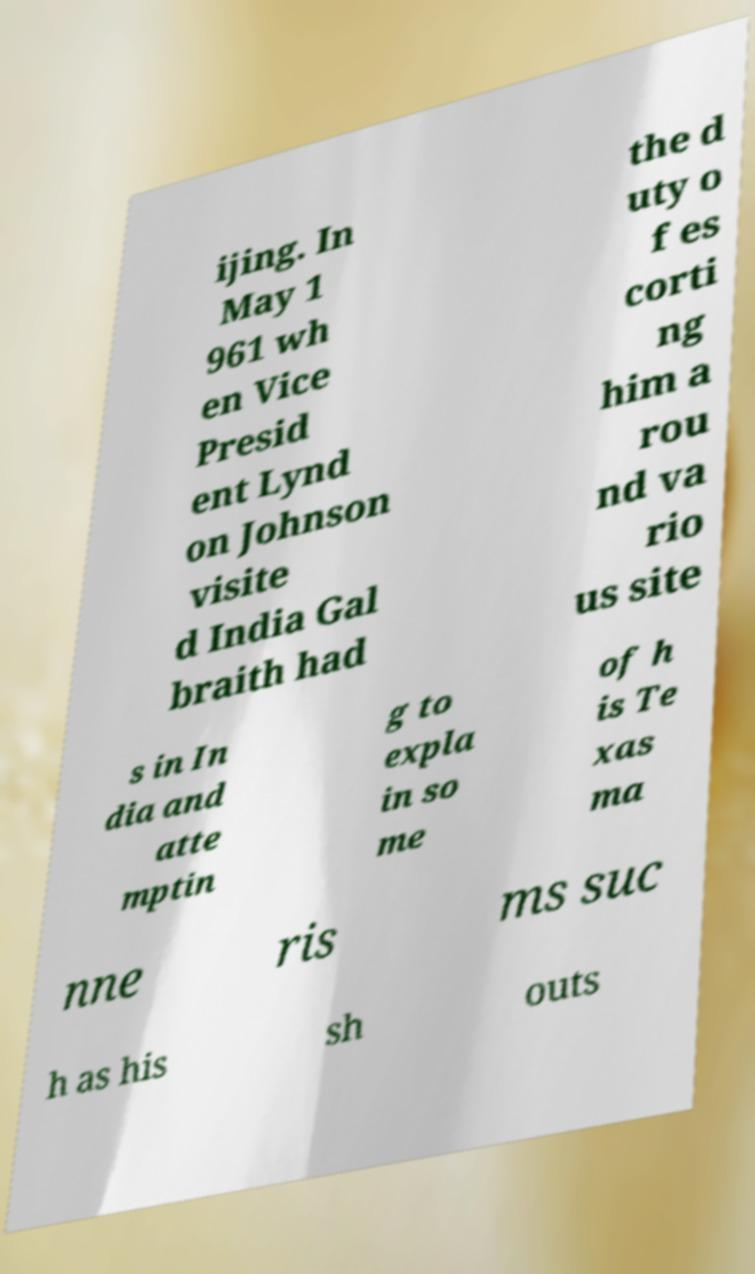Can you accurately transcribe the text from the provided image for me? ijing. In May 1 961 wh en Vice Presid ent Lynd on Johnson visite d India Gal braith had the d uty o f es corti ng him a rou nd va rio us site s in In dia and atte mptin g to expla in so me of h is Te xas ma nne ris ms suc h as his sh outs 